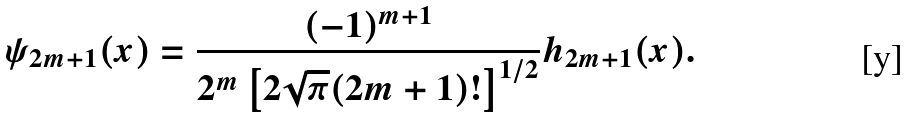<formula> <loc_0><loc_0><loc_500><loc_500>\psi _ { 2 m + 1 } ( x ) = \frac { ( - 1 ) ^ { m + 1 } } { 2 ^ { m } \left [ 2 \sqrt { \pi } ( 2 m + 1 ) ! \right ] ^ { 1 / 2 } } h _ { 2 m + 1 } ( x ) .</formula> 